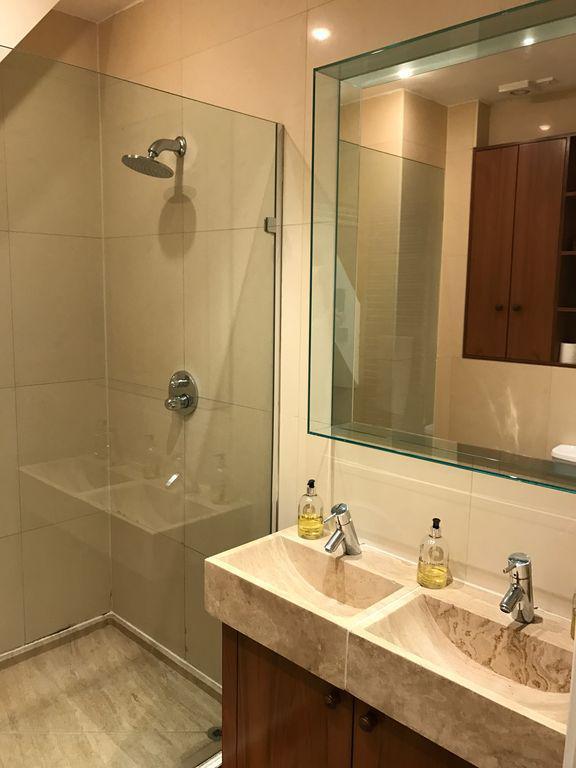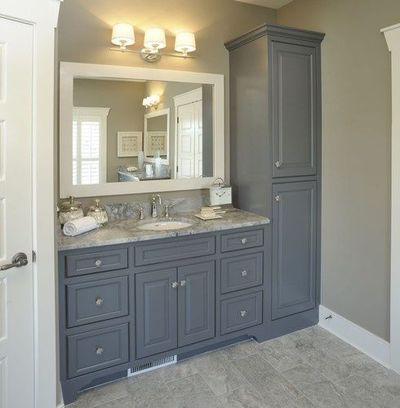The first image is the image on the left, the second image is the image on the right. Evaluate the accuracy of this statement regarding the images: "An area with two bathroom sinks and a glass shower unit can be seen in one image, while the other image shows a single sink and surrounding cabinetry.". Is it true? Answer yes or no. Yes. The first image is the image on the left, the second image is the image on the right. Assess this claim about the two images: "Right image shows only one rectangular mirror hanging over only one vanity with one sink, in a room with no bathtub visible.". Correct or not? Answer yes or no. Yes. 